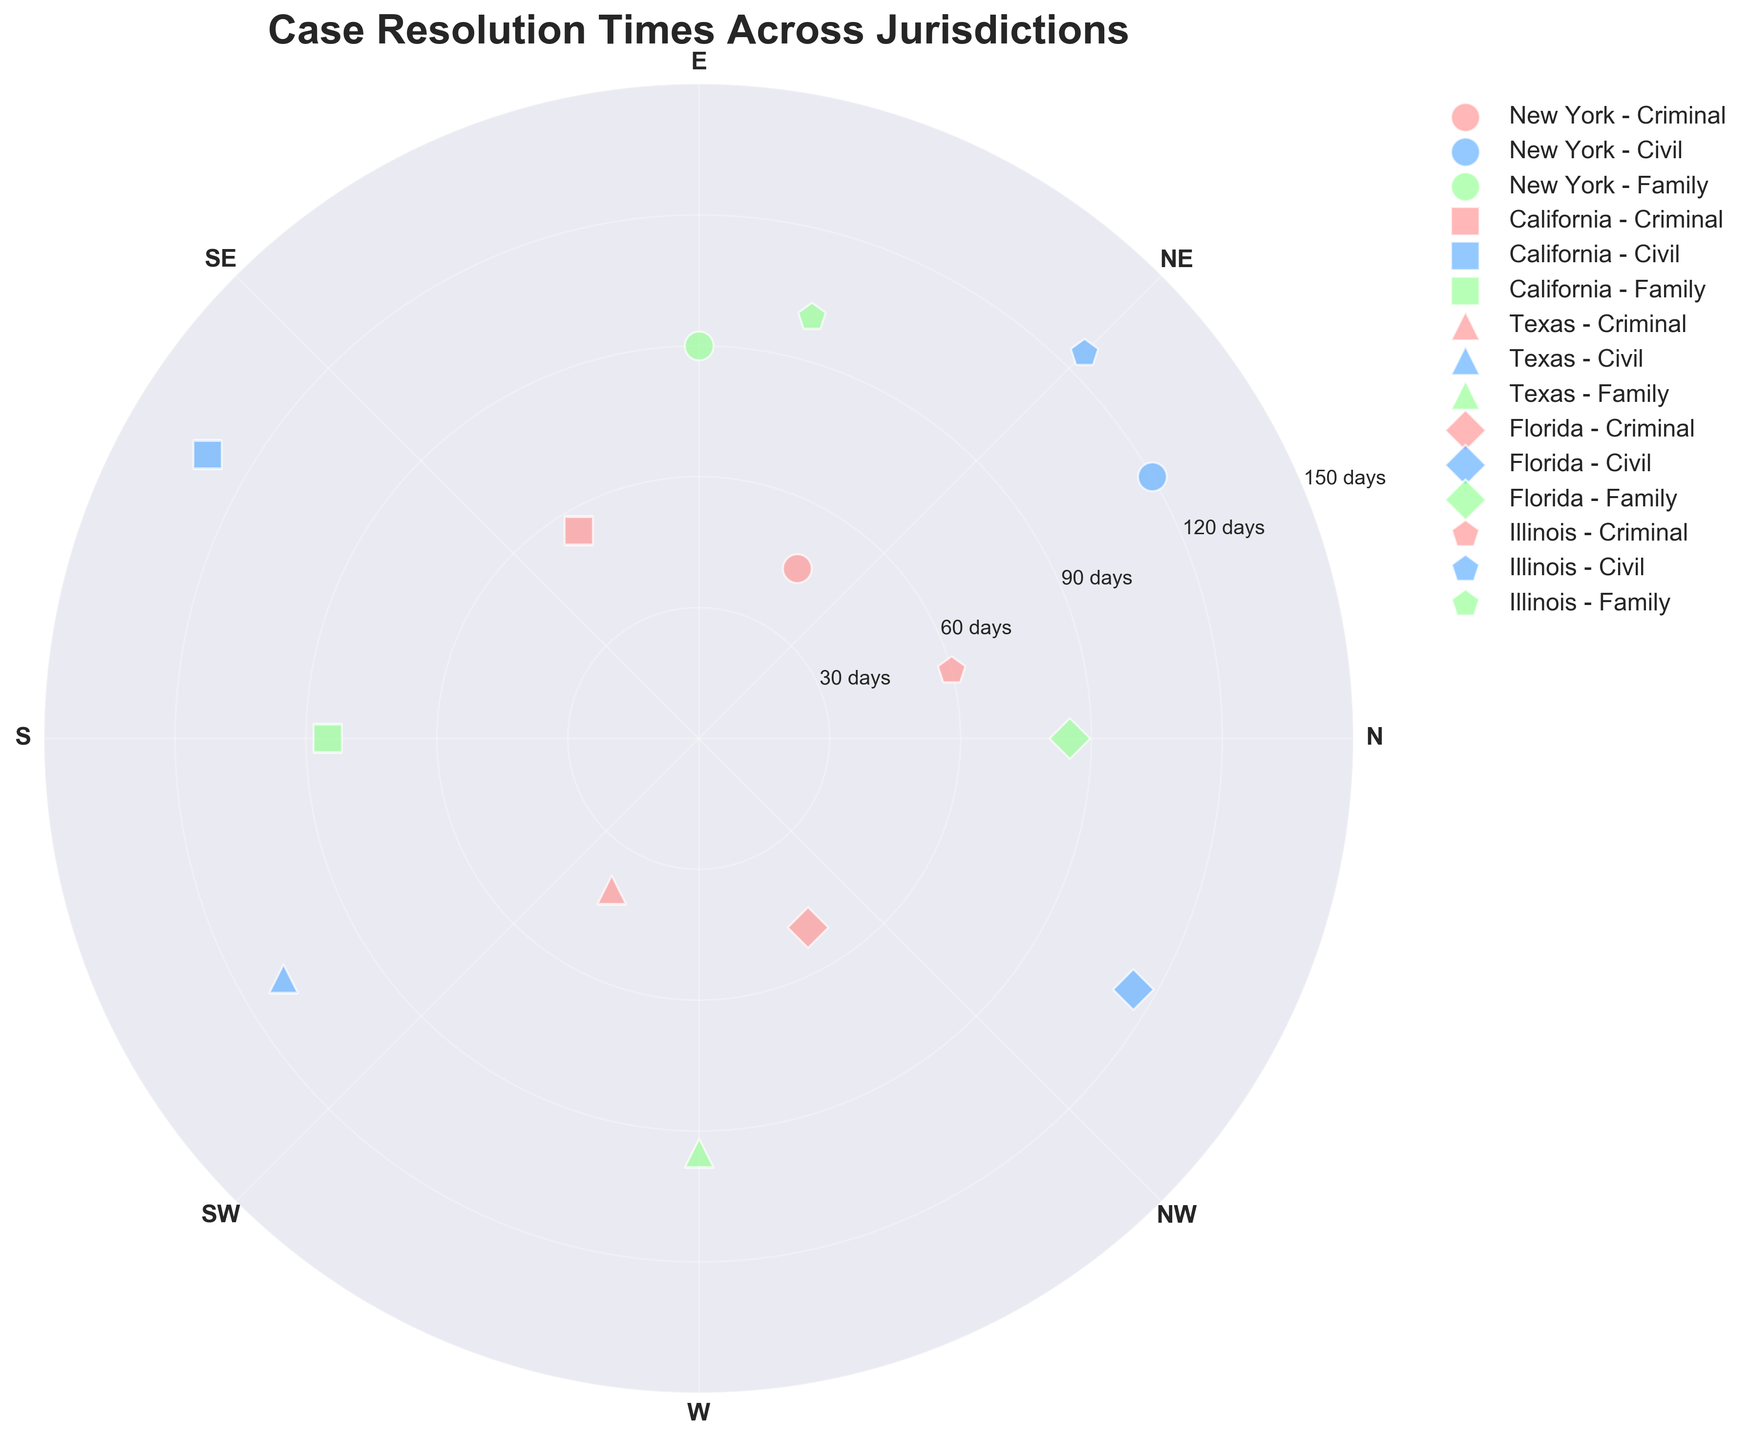What is the title of the figure? The title is usually positioned at the top of the chart. This specific chart has "Case Resolution Times Across Jurisdictions" as its title.
Answer: Case Resolution Times Across Jurisdictions What color is used to represent Criminal cases? The chart legend typically includes coloring for different case types. For Criminal cases, the color used is red or pink.
Answer: Red/Pink What is the resolution time in days for Family cases in Texas? Check the specific marker used for Texas (triangle) and the color for Family cases (green). The location for Texas Family cases shows a resolution time at 95 days.
Answer: 95 Which jurisdiction has the shortest resolution time for Criminal cases? By examining the markers and colors for Criminal cases across jurisdictions, look for the smallest value on the radial axis. Texas (triangle marker and red/pink color) has the shortest resolution time at 40 days.
Answer: Texas How many jurisdictions are represented in this chart? The legend and the different markers used identify the number of jurisdictions. Counting these, we find five: New York, California, Texas, Florida, and Illinois.
Answer: Five Which case type in California has the longest resolution time? Focus on the markers for California (square marker) and check the resolution times for different colors. Civil cases (blue) have the longest resolution time at 130 days.
Answer: Civil Compare the resolution times for Family cases between New York and Florida. Which has a longer resolution time? Find the green markers for both New York (circle) and Florida (diamond), then compare their positions on the radial axis. New York has a resolution time of 90 days, while Florida has 85 days, meaning New York is longer.
Answer: New York What are the radial axis limits set in the chart? By looking at the radial axis labels, we can see the minimum and maximum values defined. The limits are from 0 to 150 days.
Answer: 0 to 150 days Which jurisdiction has the shortest and longest Family case resolution time, and what are those times? Examine the green markers for all jurisdictions and identify the shortest and longest times. Florida and California have the shortest time at 85 days, and Illinois has the longest at 100 days.
Answer: Shortest: Florida/California (85 days), Longest: Illinois (100 days) If you average the resolution times for Criminal cases across all jurisdictions, what is the average? Sum the resolution times for Criminal cases: 45 (New York) + 55 (California) + 40 (Texas) + 50 (Florida) + 60 (Illinois) = 250 days. Divide by 5 jurisdictions, so the average is 250/5 = 50 days.
Answer: 50 days 